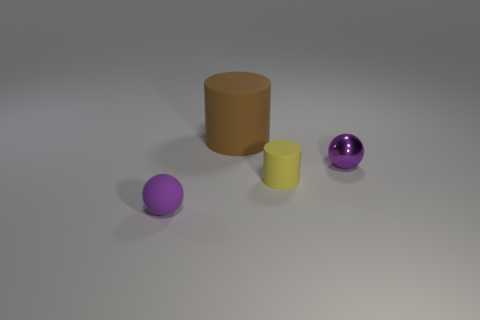Are there any other things that have the same size as the brown object?
Your answer should be very brief. No. Is the small yellow matte thing the same shape as the big brown rubber object?
Provide a succinct answer. Yes. There is another object that is the same shape as the purple shiny object; what is its material?
Your answer should be very brief. Rubber. What number of matte balls have the same color as the metal thing?
Your answer should be very brief. 1. What is the size of the cylinder that is made of the same material as the yellow object?
Provide a short and direct response. Large. What number of brown things are large things or small spheres?
Offer a very short reply. 1. There is a tiny purple object that is behind the tiny purple rubber sphere; how many tiny purple rubber objects are left of it?
Provide a short and direct response. 1. Is the number of purple shiny objects on the right side of the tiny yellow rubber object greater than the number of brown matte objects in front of the rubber ball?
Ensure brevity in your answer.  Yes. What material is the tiny yellow cylinder?
Your answer should be very brief. Rubber. Is there another object of the same size as the purple rubber object?
Ensure brevity in your answer.  Yes. 